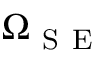<formula> <loc_0><loc_0><loc_500><loc_500>\Omega _ { S E }</formula> 